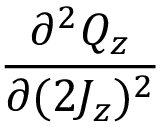Convert formula to latex. <formula><loc_0><loc_0><loc_500><loc_500>\frac { \partial ^ { 2 } Q _ { z } } { \partial ( 2 J _ { z } ) ^ { 2 } }</formula> 